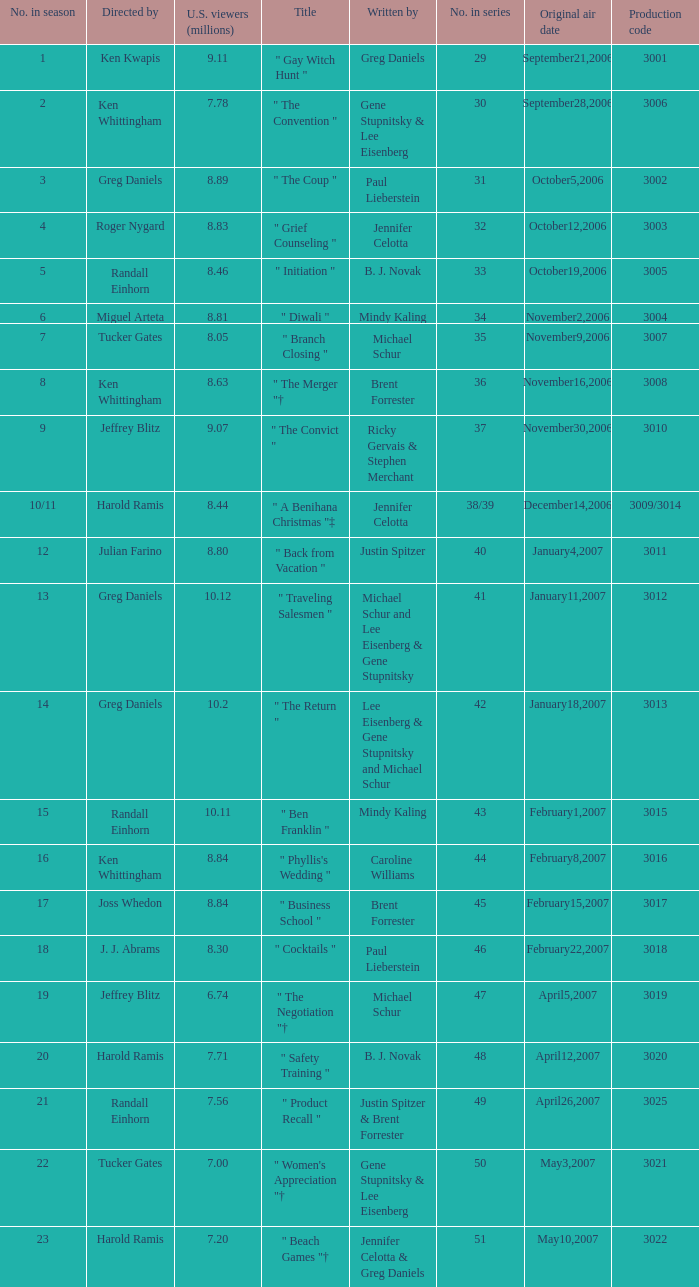Could you parse the entire table? {'header': ['No. in season', 'Directed by', 'U.S. viewers (millions)', 'Title', 'Written by', 'No. in series', 'Original air date', 'Production code'], 'rows': [['1', 'Ken Kwapis', '9.11', '" Gay Witch Hunt "', 'Greg Daniels', '29', 'September21,2006', '3001'], ['2', 'Ken Whittingham', '7.78', '" The Convention "', 'Gene Stupnitsky & Lee Eisenberg', '30', 'September28,2006', '3006'], ['3', 'Greg Daniels', '8.89', '" The Coup "', 'Paul Lieberstein', '31', 'October5,2006', '3002'], ['4', 'Roger Nygard', '8.83', '" Grief Counseling "', 'Jennifer Celotta', '32', 'October12,2006', '3003'], ['5', 'Randall Einhorn', '8.46', '" Initiation "', 'B. J. Novak', '33', 'October19,2006', '3005'], ['6', 'Miguel Arteta', '8.81', '" Diwali "', 'Mindy Kaling', '34', 'November2,2006', '3004'], ['7', 'Tucker Gates', '8.05', '" Branch Closing "', 'Michael Schur', '35', 'November9,2006', '3007'], ['8', 'Ken Whittingham', '8.63', '" The Merger "†', 'Brent Forrester', '36', 'November16,2006', '3008'], ['9', 'Jeffrey Blitz', '9.07', '" The Convict "', 'Ricky Gervais & Stephen Merchant', '37', 'November30,2006', '3010'], ['10/11', 'Harold Ramis', '8.44', '" A Benihana Christmas "‡', 'Jennifer Celotta', '38/39', 'December14,2006', '3009/3014'], ['12', 'Julian Farino', '8.80', '" Back from Vacation "', 'Justin Spitzer', '40', 'January4,2007', '3011'], ['13', 'Greg Daniels', '10.12', '" Traveling Salesmen "', 'Michael Schur and Lee Eisenberg & Gene Stupnitsky', '41', 'January11,2007', '3012'], ['14', 'Greg Daniels', '10.2', '" The Return "', 'Lee Eisenberg & Gene Stupnitsky and Michael Schur', '42', 'January18,2007', '3013'], ['15', 'Randall Einhorn', '10.11', '" Ben Franklin "', 'Mindy Kaling', '43', 'February1,2007', '3015'], ['16', 'Ken Whittingham', '8.84', '" Phyllis\'s Wedding "', 'Caroline Williams', '44', 'February8,2007', '3016'], ['17', 'Joss Whedon', '8.84', '" Business School "', 'Brent Forrester', '45', 'February15,2007', '3017'], ['18', 'J. J. Abrams', '8.30', '" Cocktails "', 'Paul Lieberstein', '46', 'February22,2007', '3018'], ['19', 'Jeffrey Blitz', '6.74', '" The Negotiation "†', 'Michael Schur', '47', 'April5,2007', '3019'], ['20', 'Harold Ramis', '7.71', '" Safety Training "', 'B. J. Novak', '48', 'April12,2007', '3020'], ['21', 'Randall Einhorn', '7.56', '" Product Recall "', 'Justin Spitzer & Brent Forrester', '49', 'April26,2007', '3025'], ['22', 'Tucker Gates', '7.00', '" Women\'s Appreciation "†', 'Gene Stupnitsky & Lee Eisenberg', '50', 'May3,2007', '3021'], ['23', 'Harold Ramis', '7.20', '" Beach Games "†', 'Jennifer Celotta & Greg Daniels', '51', 'May10,2007', '3022']]} Name the number in the series for when the viewers is 7.78 30.0. 